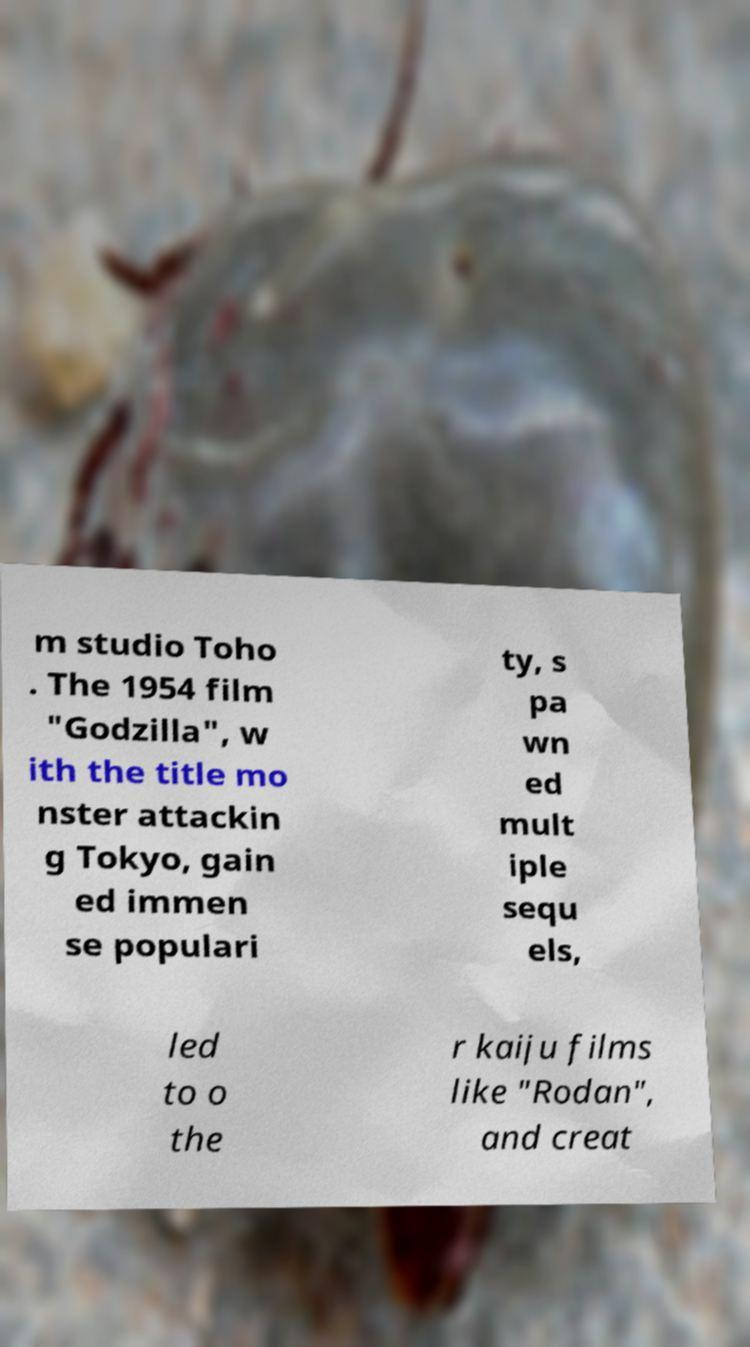For documentation purposes, I need the text within this image transcribed. Could you provide that? m studio Toho . The 1954 film "Godzilla", w ith the title mo nster attackin g Tokyo, gain ed immen se populari ty, s pa wn ed mult iple sequ els, led to o the r kaiju films like "Rodan", and creat 